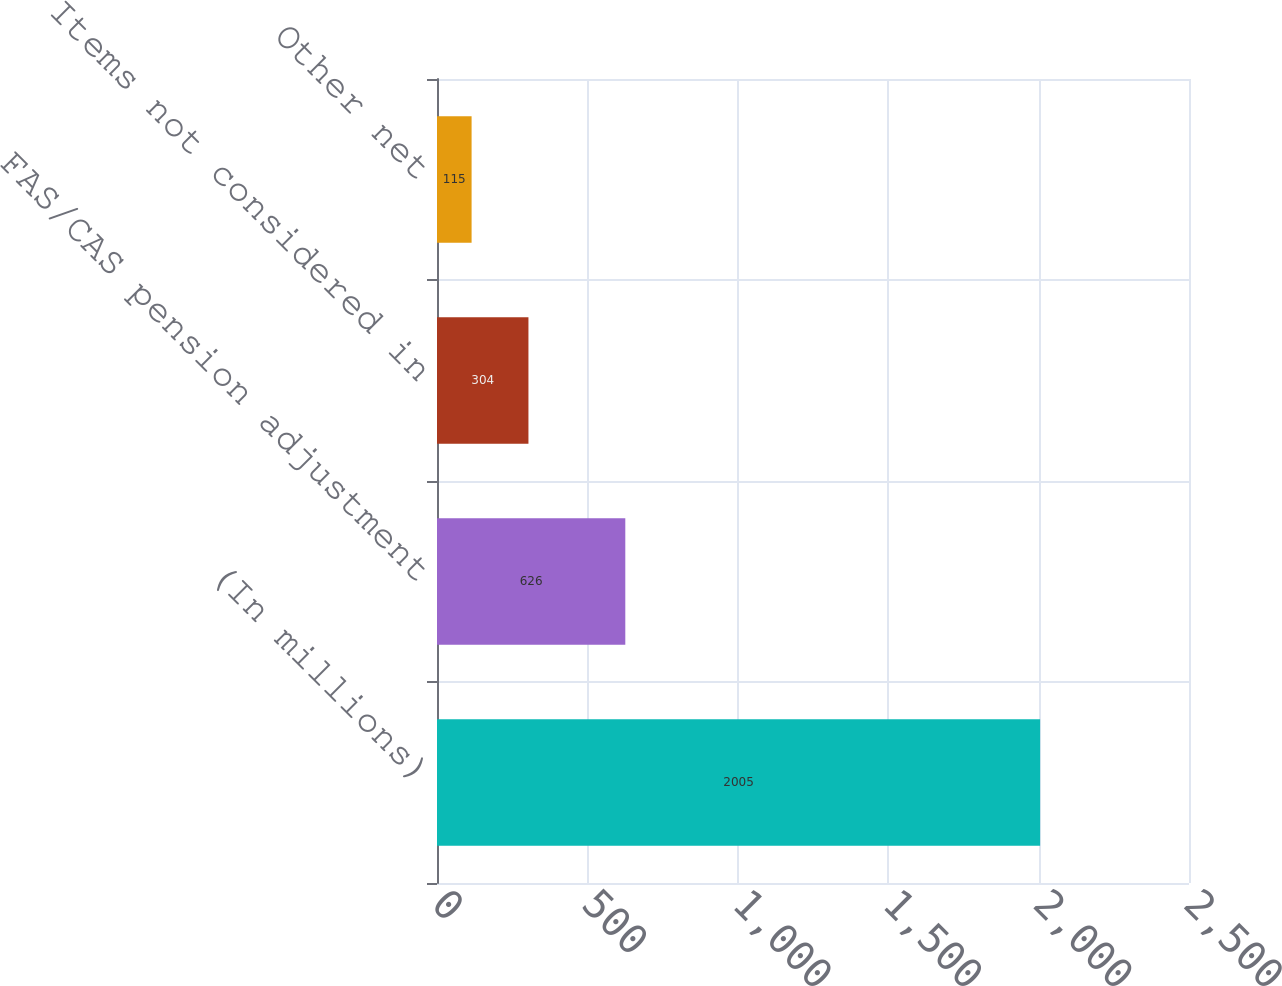<chart> <loc_0><loc_0><loc_500><loc_500><bar_chart><fcel>(In millions)<fcel>FAS/CAS pension adjustment<fcel>Items not considered in<fcel>Other net<nl><fcel>2005<fcel>626<fcel>304<fcel>115<nl></chart> 